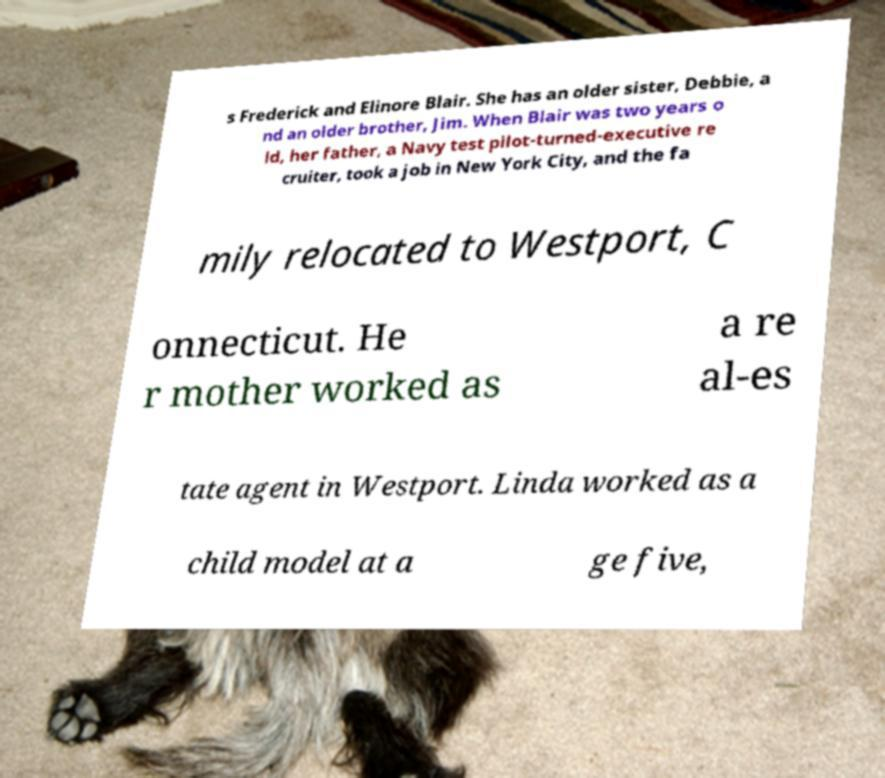Can you read and provide the text displayed in the image?This photo seems to have some interesting text. Can you extract and type it out for me? s Frederick and Elinore Blair. She has an older sister, Debbie, a nd an older brother, Jim. When Blair was two years o ld, her father, a Navy test pilot-turned-executive re cruiter, took a job in New York City, and the fa mily relocated to Westport, C onnecticut. He r mother worked as a re al-es tate agent in Westport. Linda worked as a child model at a ge five, 